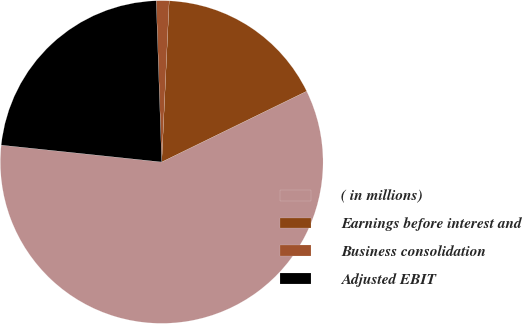Convert chart. <chart><loc_0><loc_0><loc_500><loc_500><pie_chart><fcel>( in millions)<fcel>Earnings before interest and<fcel>Business consolidation<fcel>Adjusted EBIT<nl><fcel>58.9%<fcel>17.03%<fcel>1.28%<fcel>22.79%<nl></chart> 